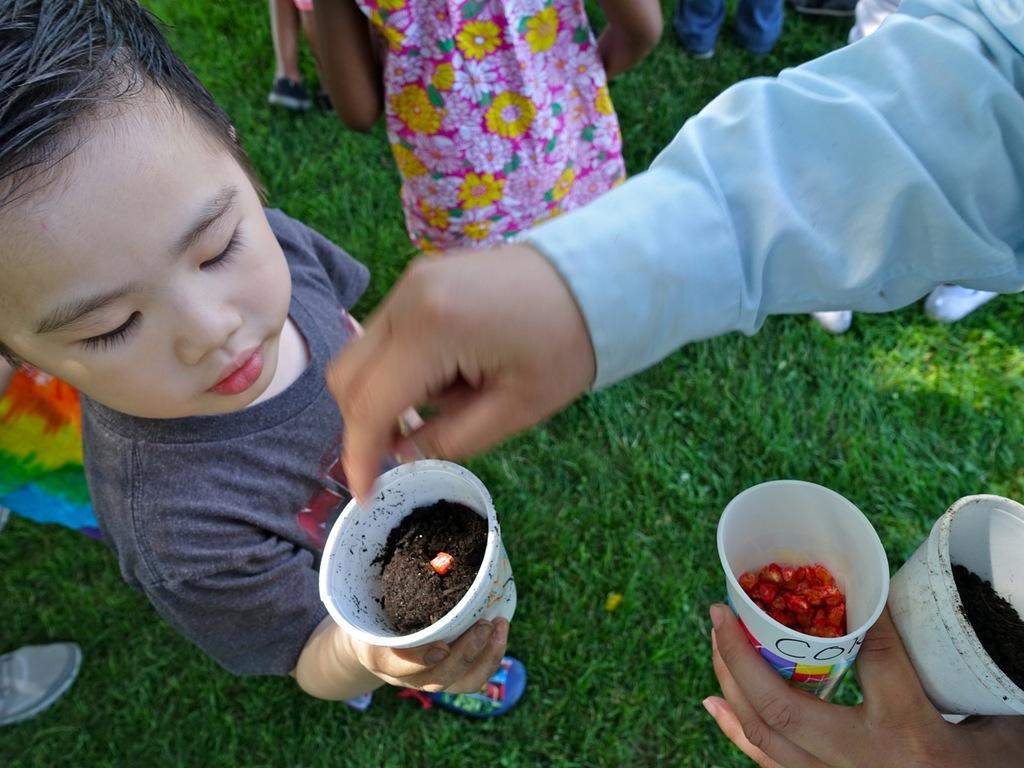Describe this image in one or two sentences. In the image we can see child wearing clothes, shoes and the child is holding a glass in hand. Here we can see other people around wearing clothes. Here we can see the grass. 